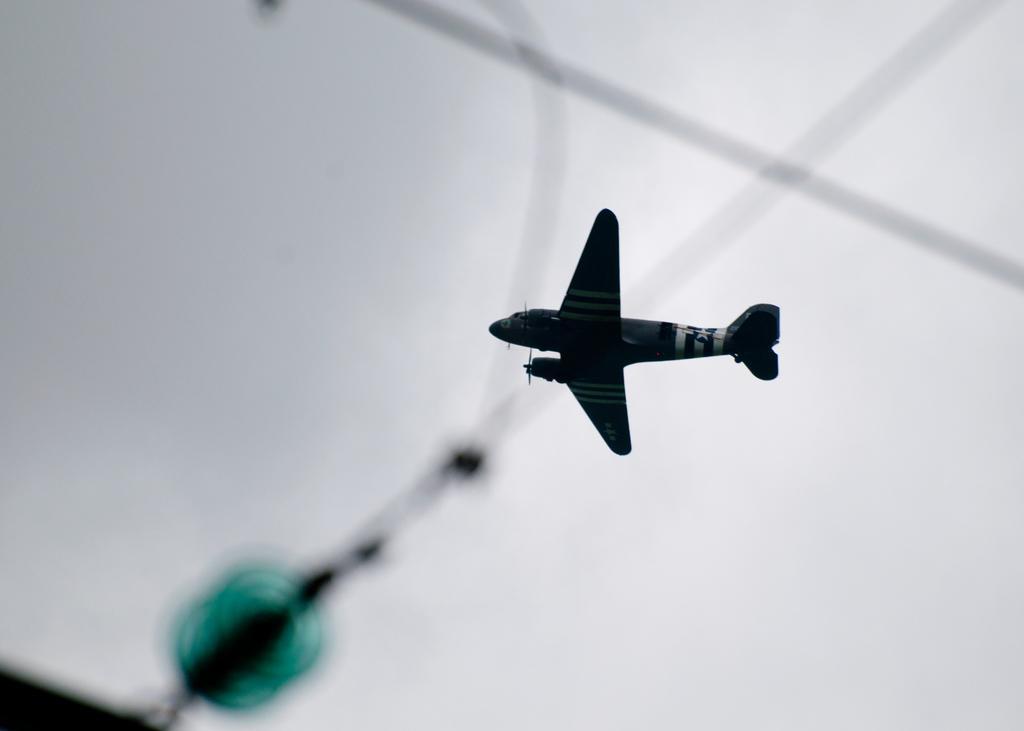Can you describe this image briefly? In this image we can see an aeroplane flying in the sky and there are cables. 